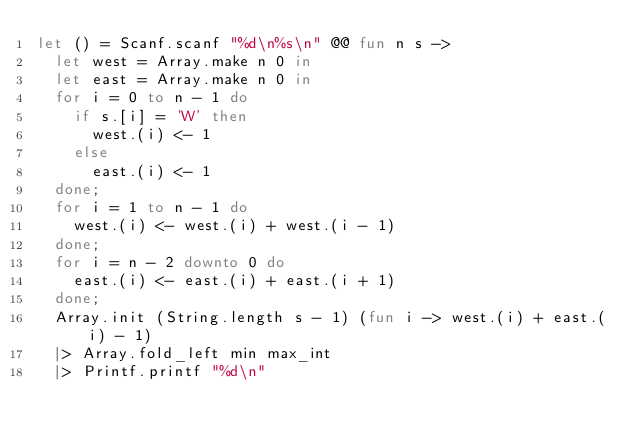<code> <loc_0><loc_0><loc_500><loc_500><_OCaml_>let () = Scanf.scanf "%d\n%s\n" @@ fun n s ->
  let west = Array.make n 0 in
  let east = Array.make n 0 in
  for i = 0 to n - 1 do
    if s.[i] = 'W' then
      west.(i) <- 1
    else 
      east.(i) <- 1
  done;
  for i = 1 to n - 1 do
    west.(i) <- west.(i) + west.(i - 1)
  done;
  for i = n - 2 downto 0 do
    east.(i) <- east.(i) + east.(i + 1)
  done;
  Array.init (String.length s - 1) (fun i -> west.(i) + east.(i) - 1)
  |> Array.fold_left min max_int
  |> Printf.printf "%d\n"</code> 